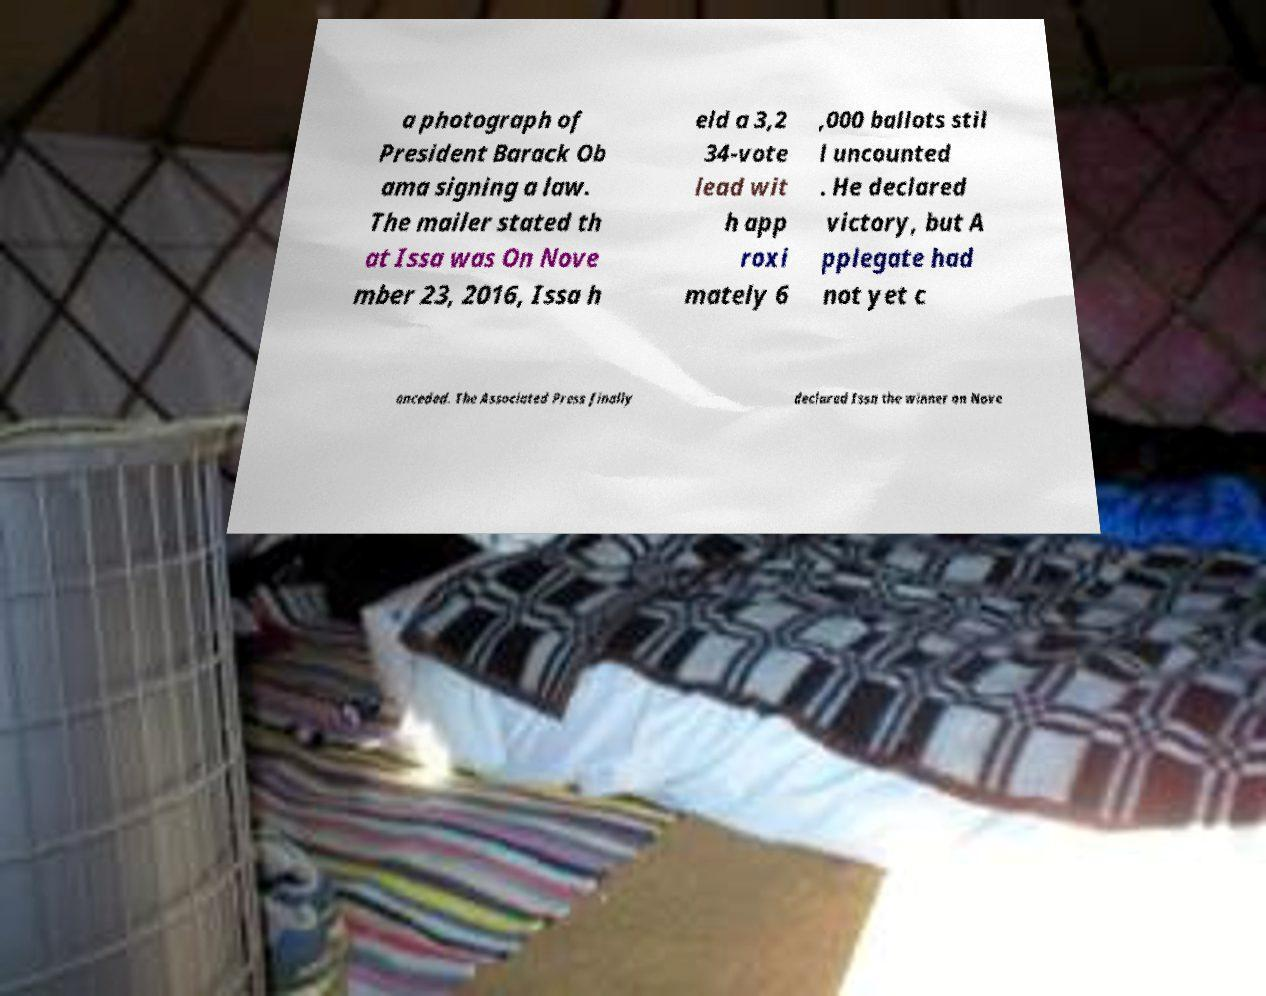For documentation purposes, I need the text within this image transcribed. Could you provide that? a photograph of President Barack Ob ama signing a law. The mailer stated th at Issa was On Nove mber 23, 2016, Issa h eld a 3,2 34-vote lead wit h app roxi mately 6 ,000 ballots stil l uncounted . He declared victory, but A pplegate had not yet c onceded. The Associated Press finally declared Issa the winner on Nove 